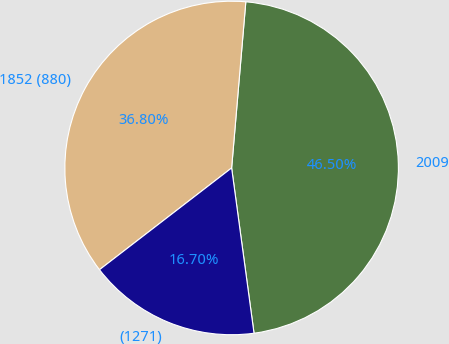Convert chart. <chart><loc_0><loc_0><loc_500><loc_500><pie_chart><fcel>2009<fcel>1852 (880)<fcel>(1271)<nl><fcel>46.5%<fcel>36.8%<fcel>16.7%<nl></chart> 